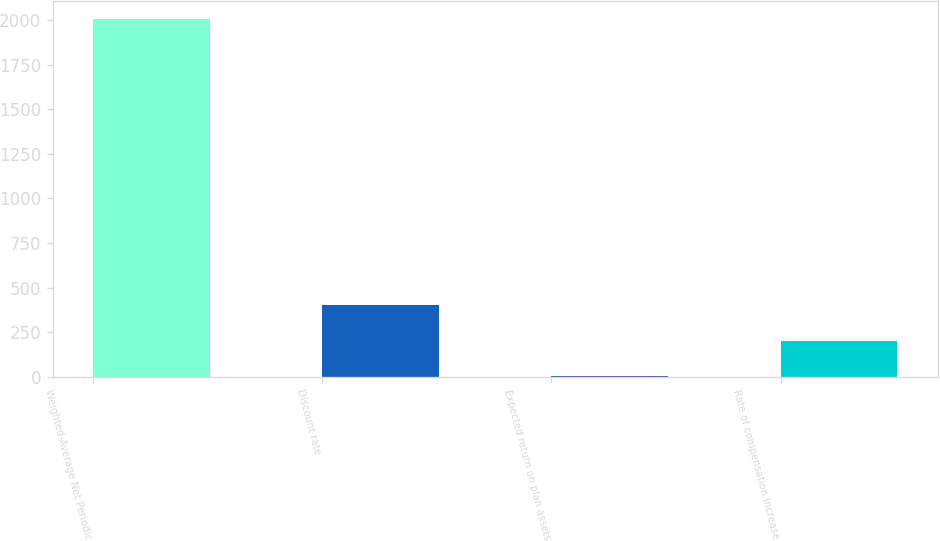Convert chart. <chart><loc_0><loc_0><loc_500><loc_500><bar_chart><fcel>Weighted-Average Net Periodic<fcel>Discount rate<fcel>Expected return on plan assets<fcel>Rate of compensation increase<nl><fcel>2008<fcel>403.72<fcel>2.64<fcel>203.18<nl></chart> 